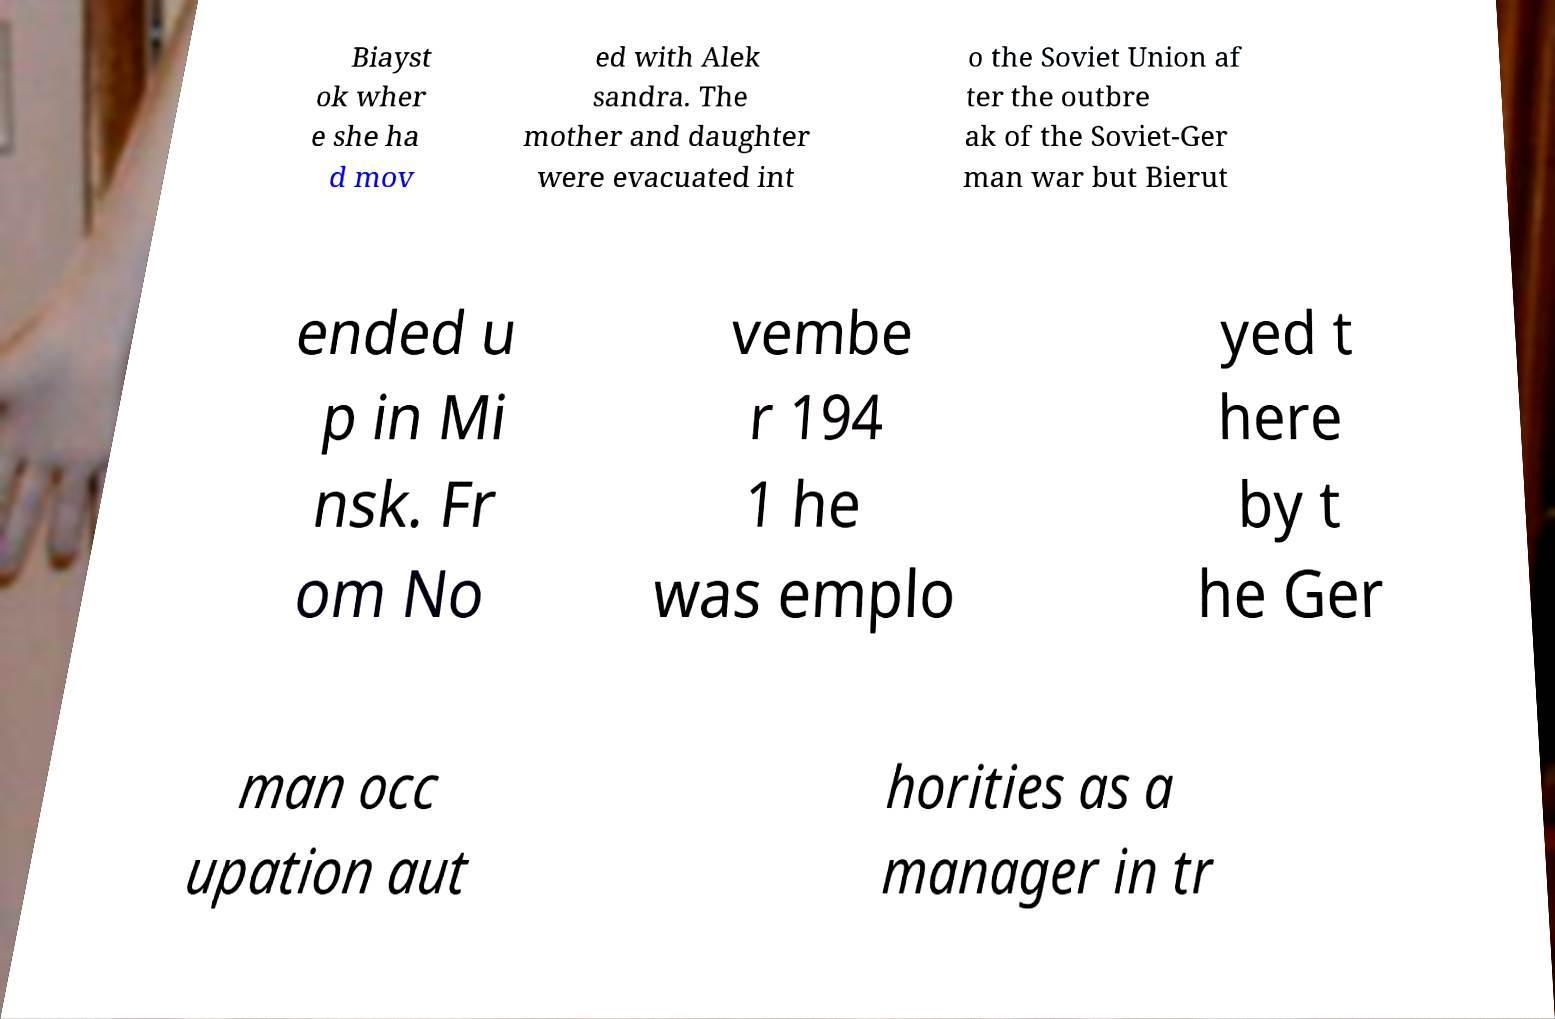What messages or text are displayed in this image? I need them in a readable, typed format. Biayst ok wher e she ha d mov ed with Alek sandra. The mother and daughter were evacuated int o the Soviet Union af ter the outbre ak of the Soviet-Ger man war but Bierut ended u p in Mi nsk. Fr om No vembe r 194 1 he was emplo yed t here by t he Ger man occ upation aut horities as a manager in tr 